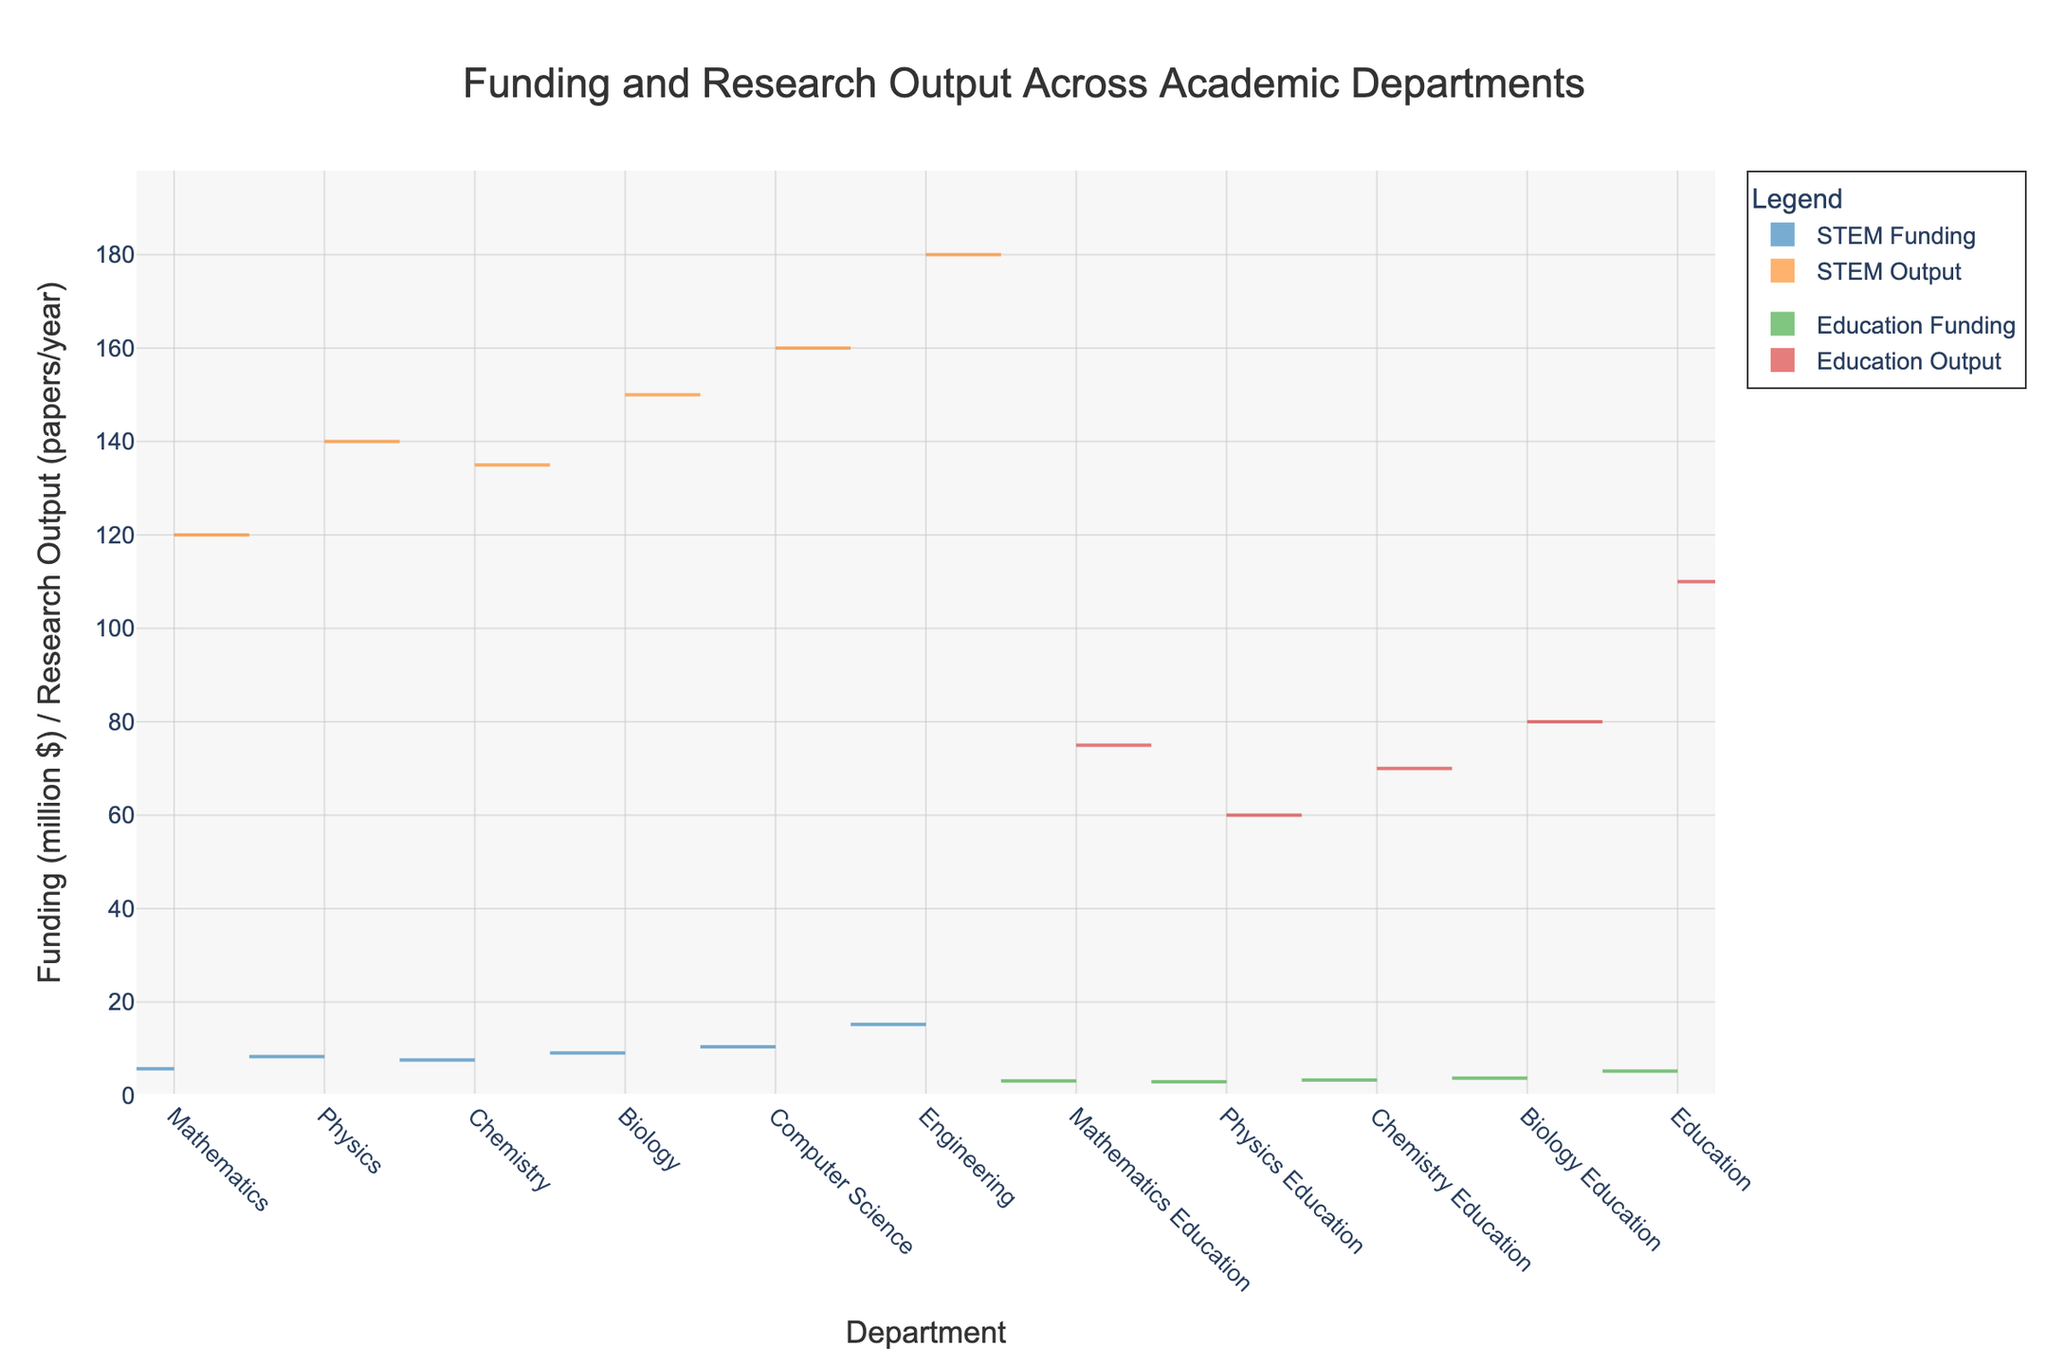What departments are shown in the x-axis of the chart? The x-axis lists the departments included in the dataset.
Answer: Mathematics, Physics, Chemistry, Biology, Computer Science, Engineering, Mathematics Education, Physics Education, Chemistry Education, Biology Education, Education What is the title of the chart? The title is displayed at the top of the chart to summarize the content.
Answer: Funding and Research Output Across Academic Departments Which department receives the highest funding among the STEM departments? By observing the violin plots on the negative side for STEM departments, we look for the highest point.
Answer: Engineering How does the research output of Mathematics Education compare to that of Physics Education? By comparing the positive side violin plots for Mathematics Education and Physics Education.
Answer: Mathematics Education has higher research output What is the range of funding values displayed on the y-axis? The y-axis indicates the range of funding values used in the chart.
Answer: 0 to around 15.2 million $ Which Education department has the lowest research output? By looking at the positive side violin plots for Education departments, we identify the lowest plot.
Answer: Physics Education Is there a correlation between funding and research output for Computer Science? Observing both the negative and positive violin plots for Computer Science shows if both metrics are high or low.
Answer: Yes, both funding and research output are high What is the total funding for the departments with 'Education' in their name? We sum the funding amounts for Mathematics Education, Physics Education, Chemistry Education, Biology Education, and Education. 3.1 + 2.9 + 3.3 + 3.7 + 5.2 = 18.2
Answer: 18.2 million $ What STEM department has the lowest research output, and how does it compare to the highest research output in the Education departments? We find the lowest research output plot on the positive side for STEM departments and compare it to the highest plot in Education departments.
Answer: Mathematics (120) is lower than Education (110) How do funding and research output distributions differ in color? Each metric is represented by a different color both for STEM and Education departments.
Answer: STEM Funding: blue, STEM Output: orange; Education Funding: green, Education Output: red 